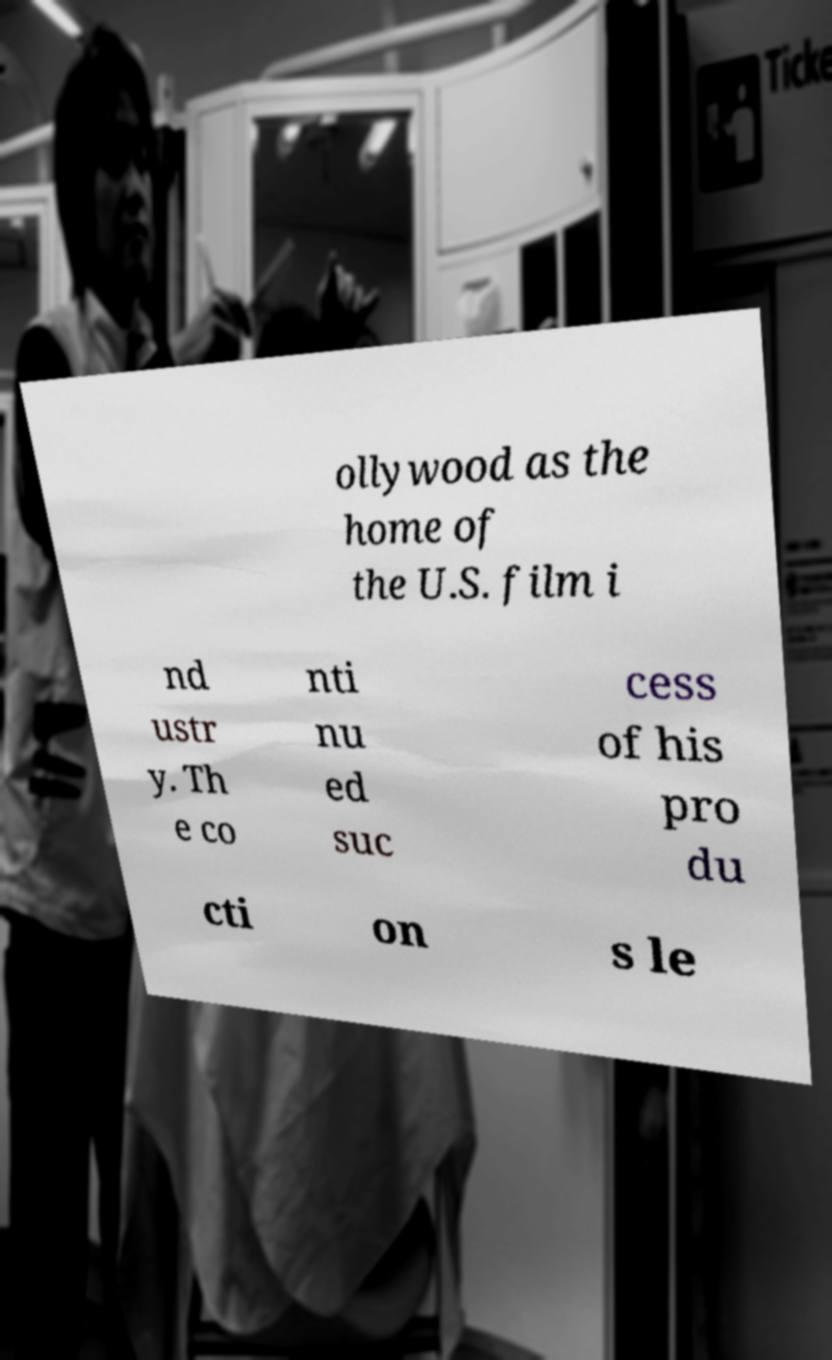I need the written content from this picture converted into text. Can you do that? ollywood as the home of the U.S. film i nd ustr y. Th e co nti nu ed suc cess of his pro du cti on s le 